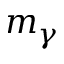<formula> <loc_0><loc_0><loc_500><loc_500>m _ { \gamma }</formula> 